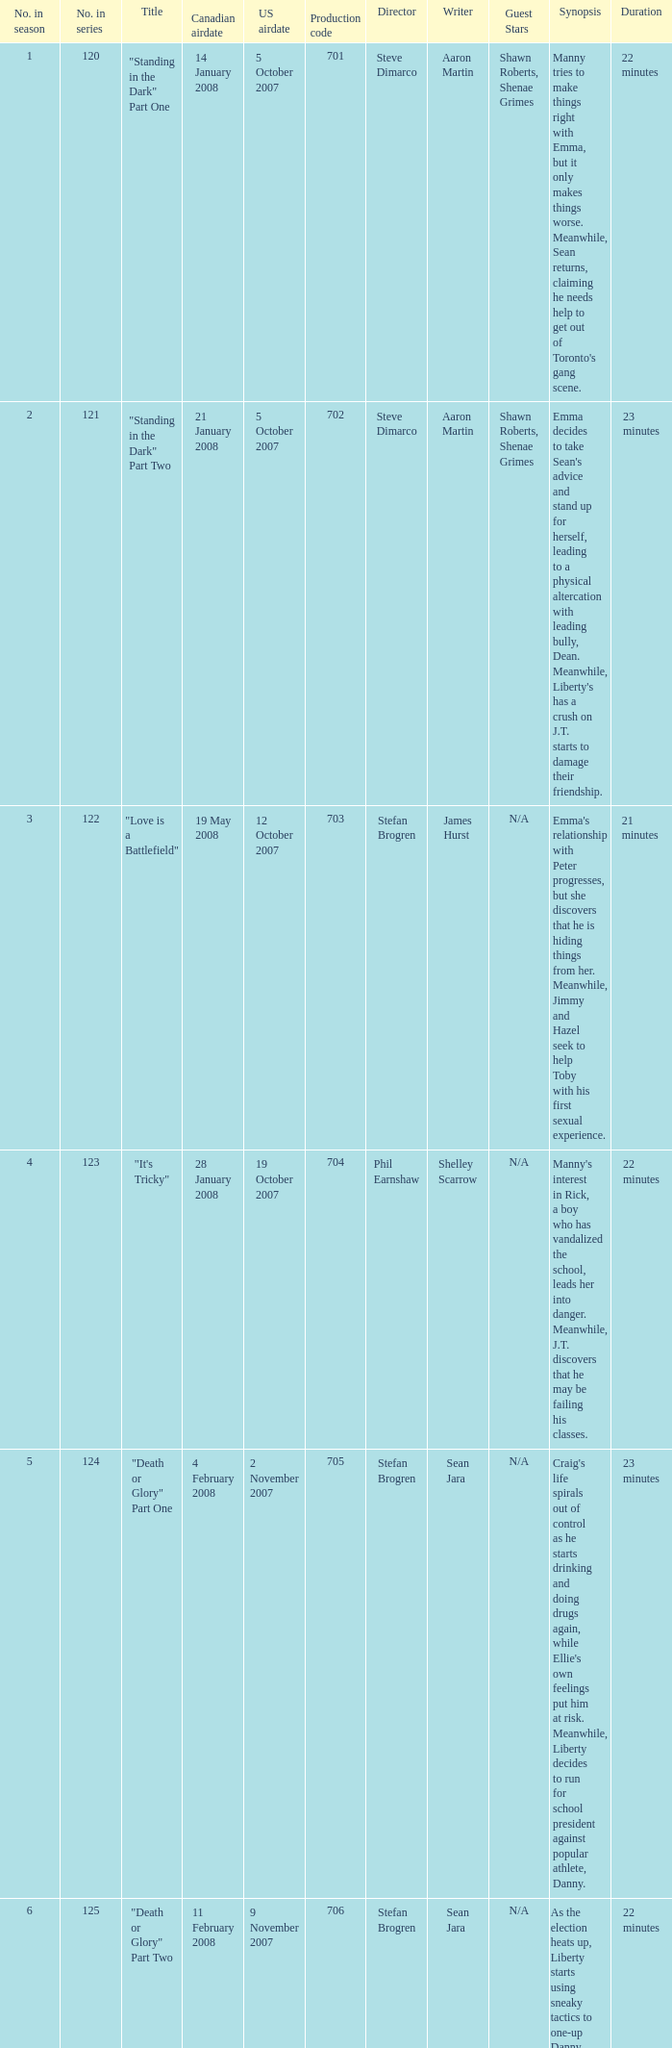For the episode(s) aired in the U.S. on 4 april 2008, what were the names? "Bust a Move" Part One, "Bust a Move" Part Two. Parse the full table. {'header': ['No. in season', 'No. in series', 'Title', 'Canadian airdate', 'US airdate', 'Production code', 'Director', 'Writer', 'Guest Stars', 'Synopsis', 'Duration'], 'rows': [['1', '120', '"Standing in the Dark" Part One', '14 January 2008', '5 October 2007', '701', 'Steve Dimarco', 'Aaron Martin', 'Shawn Roberts, Shenae Grimes', "Manny tries to make things right with Emma, but it only makes things worse. Meanwhile, Sean returns, claiming he needs help to get out of Toronto's gang scene.", '22 minutes '], ['2', '121', '"Standing in the Dark" Part Two', '21 January 2008', '5 October 2007', '702', 'Steve Dimarco', 'Aaron Martin', 'Shawn Roberts, Shenae Grimes', "Emma decides to take Sean's advice and stand up for herself, leading to a physical altercation with leading bully, Dean. Meanwhile, Liberty's has a crush on J.T. starts to damage their friendship.", '23 minutes'], ['3', '122', '"Love is a Battlefield"', '19 May 2008', '12 October 2007', '703', 'Stefan Brogren', 'James Hurst', 'N/A', "Emma's relationship with Peter progresses, but she discovers that he is hiding things from her. Meanwhile, Jimmy and Hazel seek to help Toby with his first sexual experience.", '21 minutes '], ['4', '123', '"It\'s Tricky"', '28 January 2008', '19 October 2007', '704', 'Phil Earnshaw', 'Shelley Scarrow', 'N/A', "Manny's interest in Rick, a boy who has vandalized the school, leads her into danger. Meanwhile, J.T. discovers that he may be failing his classes.", '22 minutes'], ['5', '124', '"Death or Glory" Part One', '4 February 2008', '2 November 2007', '705', 'Stefan Brogren', 'Sean Jara', 'N/A', "Craig's life spirals out of control as he starts drinking and doing drugs again, while Ellie's own feelings put him at risk. Meanwhile, Liberty decides to run for school president against popular athlete, Danny.", '23 minutes'], ['6', '125', '"Death or Glory" Part Two', '11 February 2008', '9 November 2007', '706', 'Stefan Brogren', 'Sean Jara', 'N/A', "As the election heats up, Liberty starts using sneaky tactics to one-up Danny, while Craig and Ellie's relationship becomes more complicated.", '22 minutes'], ['7', '126', '"We Got the Beat"', '18 February 2008', '16 November 2007', '707', 'Stefan Brogren', 'Duana Taha', 'N/A', "Paige discovers a love of playing the drums, while Peter's presence starts to tear apart the band. Meanwhile, Alex's strained relationship with her mother worsens.", '23 minutes'], ['8', '127', '"Jessie\'s Girl"', '25 February 2008', '8 February 2008', '708', 'Stefan Brogren', 'Sean Carley', 'N/A', "Spinner convinces Jimmy to join him at a strip club, leading to unexpected consequences. Meanwhile, Peter's relationship with Emma is tested when he shares interest in music with Manny.", '21 minutes '], ['9', '128', '"Hungry Eyes"', '3 March 2008', '15 February 2008', '709', 'Stefan Brogren', 'James Hurst', 'N/A', "Toby's love life gets complicated when he discovers that both his girlfriend and his crush are keeping secrets from him. Meanwhile, Spinner tries to get his driver's license but struggles to do so.", '22 minutes'], ['10', '129', '"Pass the Dutchie"', '10 March 2008', '22 February 2008', '710', 'Stefan Brogren', 'Aaron Martin', 'N/A', "Jimmy invites the people involved in Rick's shooting to a gathering to talk about the incident, leading to unexpected confrontations. Meanwhile, Spinner and Marco's friendship is tested when Marco starts dating Dylan, the new boy at school.", '23 minutes'], ['11', '130', '"Owner of a Lonely Heart"', '17 March 2008', '29 February 2008', '711', 'Stefan Brogren', 'Sean Reycraft', 'N/A', 'Ellie seeks comfort in a relationship with Marco, but her feelings for Craig and her self-doubt might ruin it. Meanwhile, Jimmy has to deal with the aftermath of his fight with Spinner.', '22 minutes'], ['12', '131', '"Live to Tell"', '24 March 2008', '7 March 2008', '712', 'Stefan Brogren', 'Shelley Scarrow', 'N/A', "Emma's new video project exposes secrets about relationships and sex that most would rather keep hidden. Meanwhile, Paige's unresolved feelings for a former girlfriend complicate her relationship with Alex.", '23 minutes'], ['13', '132', '"Bust a Move" Part One', '31 March 2008', '4 April 2008', '713', 'Stefan Brogren', 'Yan Moore', 'Cassie Steele, Lauren Collins, Jake Epstein', 'Jay and Spinner\'s business selling "Spinner-Approved" lunches becomes a success but puts them into conflict with the school administration. Meanwhile, the school plays host to the national cheerleading championships, and Liberty becomes the captain of the cheerleading squad.', '22 minutes '], ['14', '133', '"Bust a Move" Part Two', '7 April 2008', '4 April 2008', '714', 'Stefan Brogren', 'Yan Moore', 'Cassie Steele, Lauren Collins, Jake Epstein', 'The end of the year is approaching, and the students of Degrassi Street have to put up with final exams, prom, and graduation. Meanwhile, Ellie tries to convince Marco to come out to his mother, and Liberty struggles to find a date for prom.', '23 minutes '], ['15', '134', '"Got My Mind Set on You"', '14 April 2008', '11 April 2008', '715', 'Stefan Brogren', 'Sean Reycraft', 'N/A', "Spinner and Jane's relationship is tested when Jane is caught cheating on a test. Meanwhile, Holly J. and Anya's friendship threatens to end due to uncertain circumstances.", '22 minutes '], ['16', '135', '"Sweet Child o\' Mine"', '21 April 2008', '18 April 2008', '716', 'Sean Mc Carthy', 'James Hurst', 'N/A', "When the school hosts a Battle of the Bands competition, rivalries both new and old flare up, and relationships are put to the test. Meanwhile, Sav tries to win over Anya's family to gain their approval.", '23 minutes '], ['17', '136', '"Talking in Your Sleep"', '28 April 2008', '9 May 2008', '717', 'Stefan Brogren', 'Duana Taha', 'N/A', 'Jane starts acting differently after being dumped by Spinner, causing everyone to worry about her behavior. Meanwhile, Holly J. tries to gain popularity by using Anya as her guinea pig.', '22 minutes'], ['18', '137', '"Another Brick in the Wall"', '5 May 2008', '25 April 2008', '718', 'Stefan Brogren', 'Michael Grassi', 'N/A', "Ellie gets assigned to work with Marco on a project about breast cancer. Meanwhile, Declan's arrival at Degrassi makes Fiona question her own identity and her relationship with Bobby.", '23 minutes'], ['19', '138', '"Broken Wings"', '12 May 2008', '11 July 2008', '719', 'Stefan Brogren', 'James Hurst', 'N/A', "When the band goes on a trip to New York, Peter's ego starts to get out of control. Meanwhile, Paige and Alex's relationship is tested by Alex's aloofness and Paige's insecurities.", '22 minutes '], ['20', '139', '"Ladies\' Night"', '26 May 2008', '18 July 2008', '720', 'Phil Earnshaw', 'Sean Carley', 'N/A', 'Chantay tries to impress Danny by becoming a "bad girl", but it leads to unexpected consequences. Meanwhile, Holly J. and Jane\'s friendship is tested when Jane starts hanging out with the popular girls.', '23 minutes '], ['21', '140', '"Everything She Wants"', '2 June 2008', '11 July 2008', '721', 'Stefan Brogren', 'Mike Moore', 'N/A', "Mia struggles to balance modeling and being a single mother, and her decision to quit school angers Anya. Meanwhile, Sav tries to reconcile his affection for his sister's best friend, Anya, with his devout Muslim faith.", '22 minutes '], ['22', '141', '"Don\'t Stop Believin\'"', '9 June 2008', '25 July 2008', '722', 'Stefan Brogren', 'James Hurst', 'N/A', 'Emma tries to convince Manny that she should take her time in deciding on colleges. Meanwhile, Holly J. and Anya try to one-up each other with their prom dresses.', '23 minutes '], ['23', '142', '"If This Is It"', '16 June 2008', '8 August 2008', '723', 'Stefan Brogren', 'Tassie Cameron', 'N/A', "Paige thinks that she has the perfect end of high school experience planned, but everything goes awry. Meanwhile, Marco's graduation is bittersweet, his future with Dylan uncertain.", '22 minutes']]} 